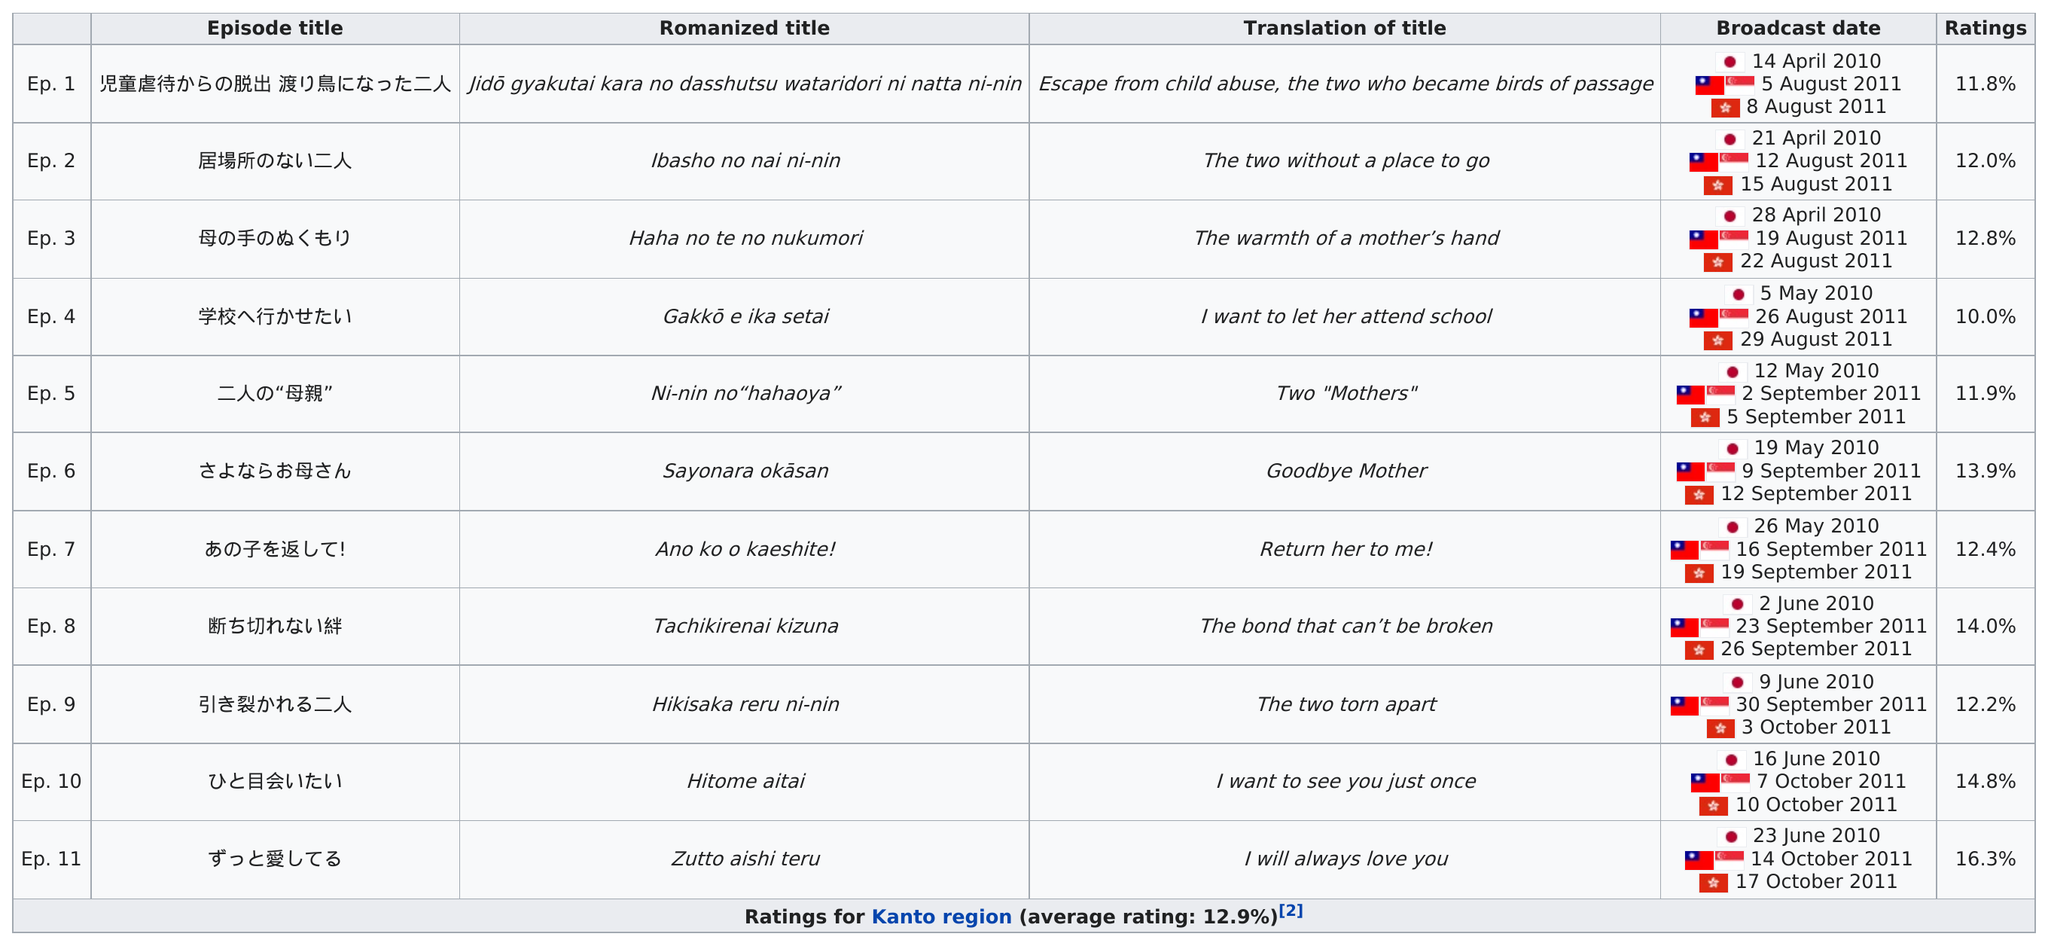Specify some key components in this picture. The name of the first episode of the show "Children's Cruelty to Break Free: Two People Who Became Cranes" is "Episode 1: Child Abuse to Break Free". The question is asking for the number of episodes that had a consecutive rating over 11%. There are 11 episodes listed. In episode four of the series, the main character expressed his desire to allow the woman he loves to attend school. The next episode after "Goodbye, Mother" was titled "The Child Returns!" (私が母の子を返す！, Watashi ga Haha no Ko o Kuru). 